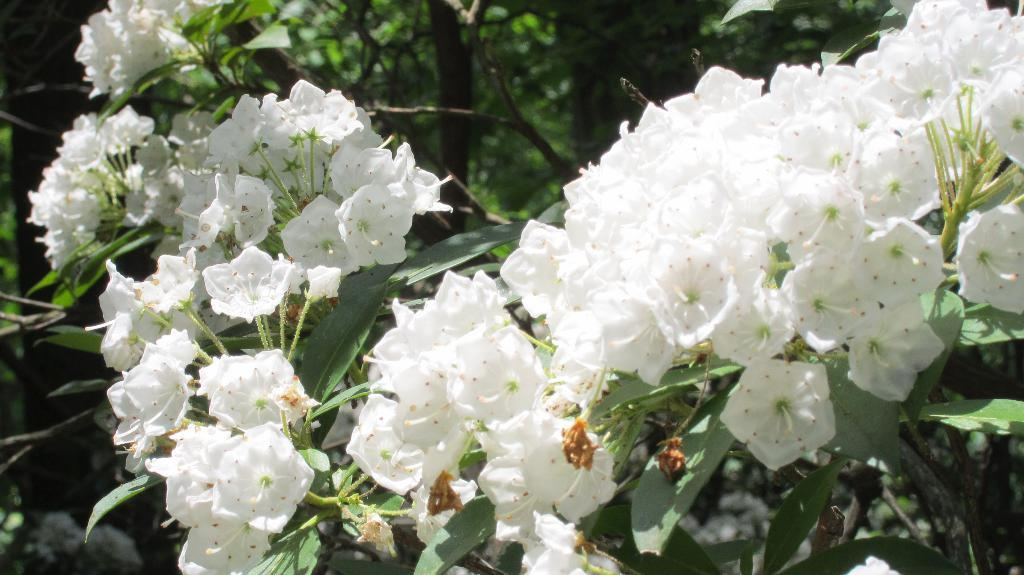What type of plants are present in the image? There are white mountain laurel flower plants in the image. Can you describe the appearance of the plants? The plants have white flowers. How many men are wearing a badge in the image? There are no men or badges present in the image; it features white mountain laurel flower plants. 